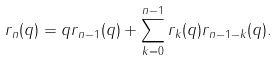<formula> <loc_0><loc_0><loc_500><loc_500>r _ { n } ( q ) = q r _ { n - 1 } ( q ) + \sum _ { k = 0 } ^ { n - 1 } r _ { k } ( q ) r _ { n - 1 - k } ( q ) .</formula> 